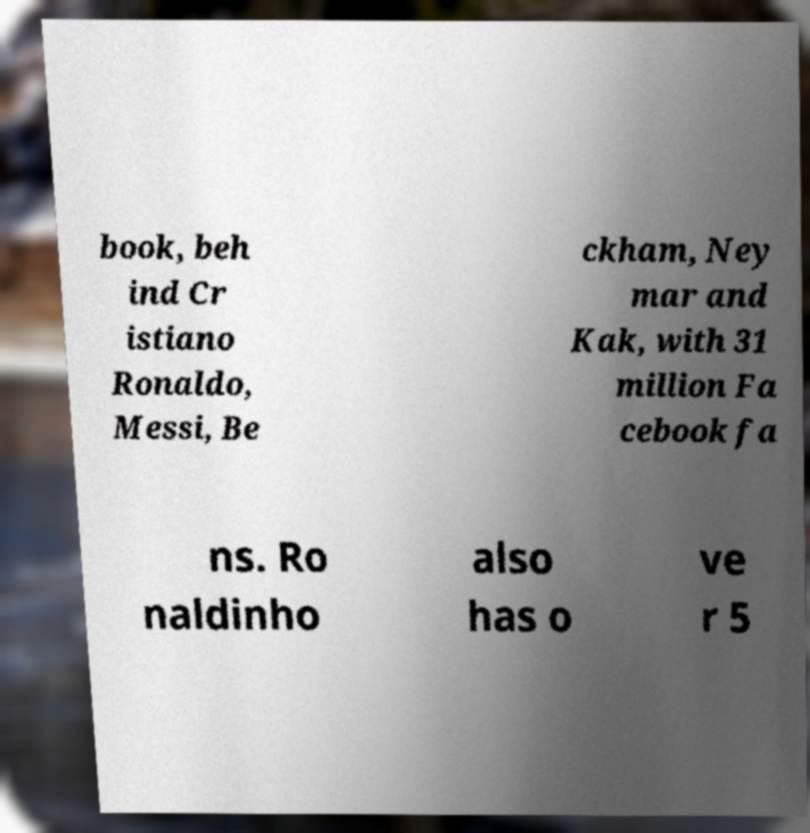There's text embedded in this image that I need extracted. Can you transcribe it verbatim? book, beh ind Cr istiano Ronaldo, Messi, Be ckham, Ney mar and Kak, with 31 million Fa cebook fa ns. Ro naldinho also has o ve r 5 